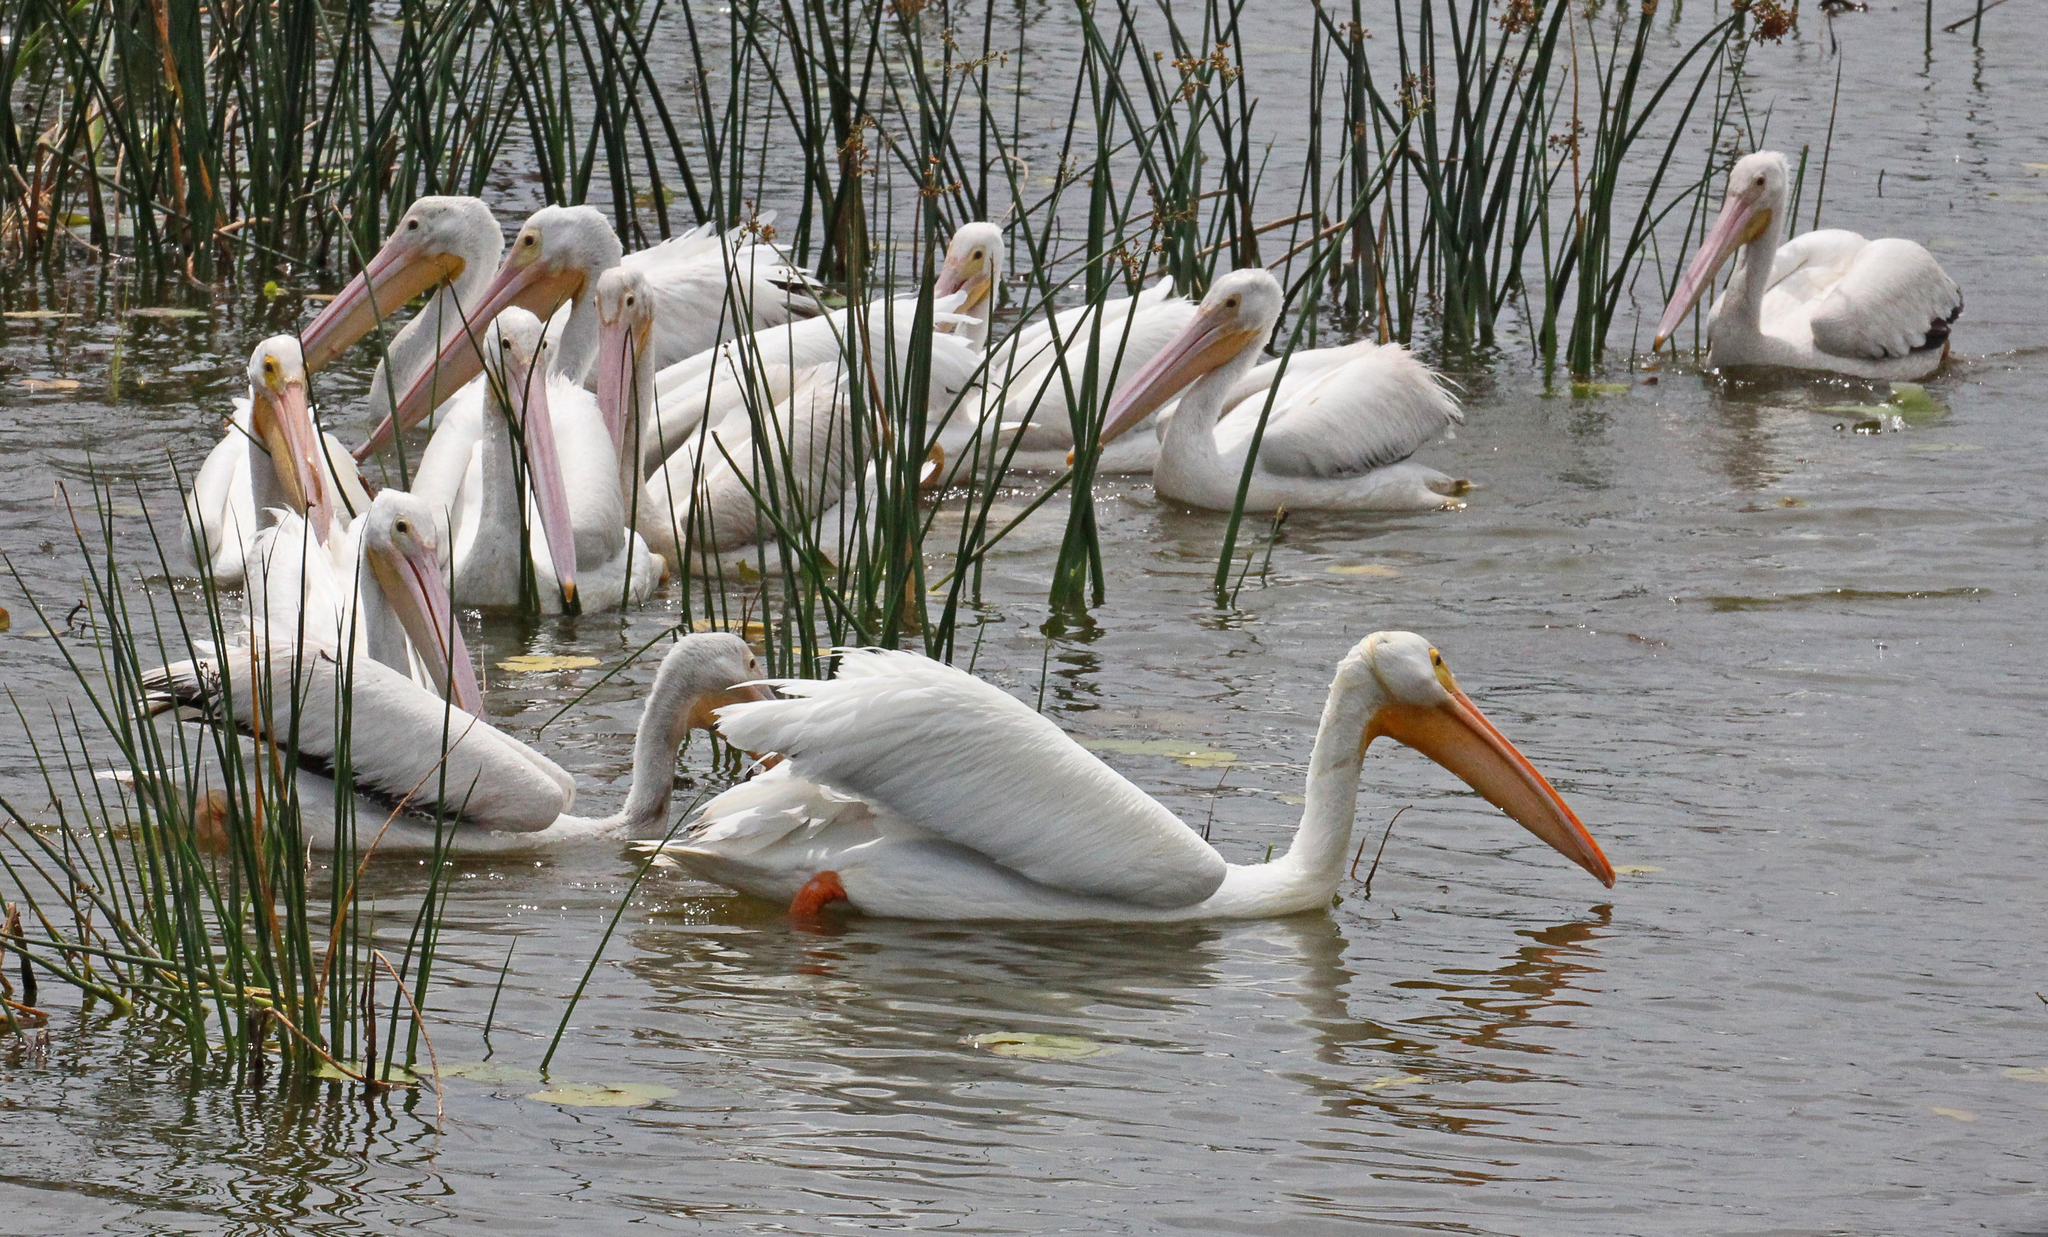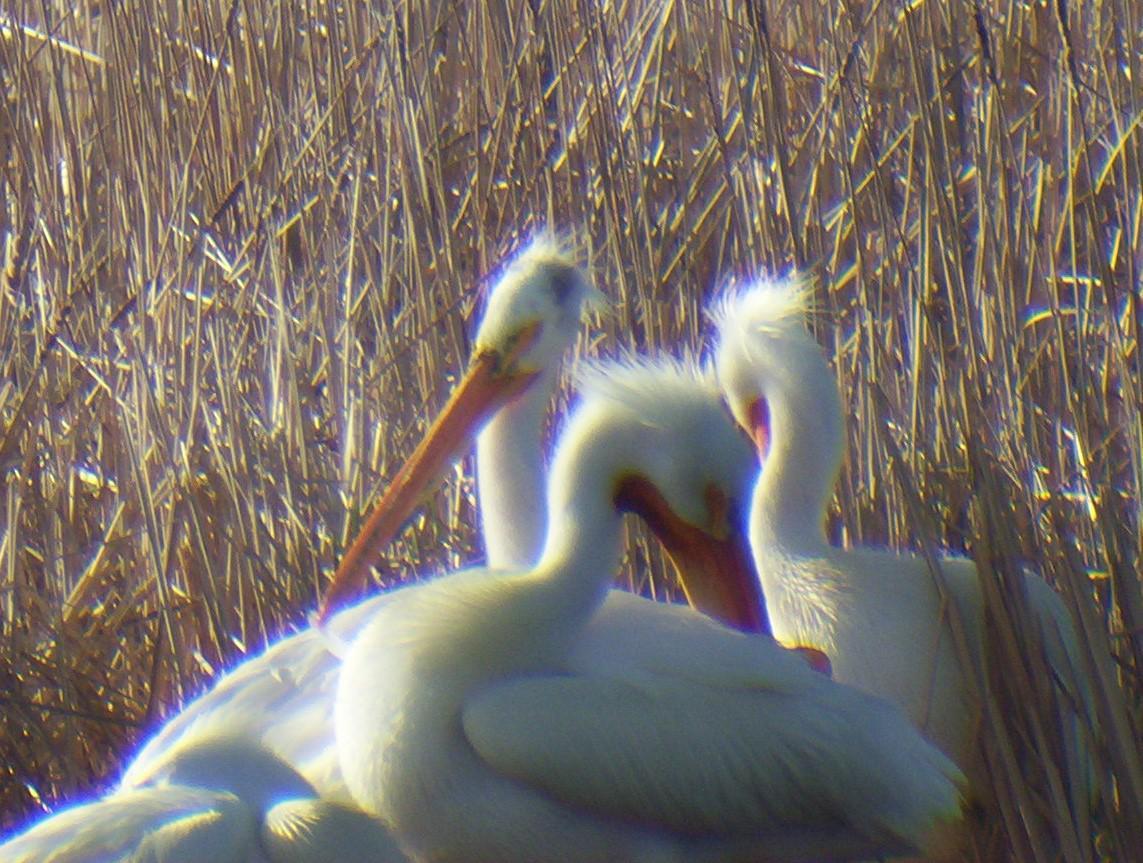The first image is the image on the left, the second image is the image on the right. Evaluate the accuracy of this statement regarding the images: "An image features exactly three pelicans, all facing the same way.". Is it true? Answer yes or no. No. 